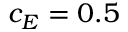Convert formula to latex. <formula><loc_0><loc_0><loc_500><loc_500>c _ { E } = 0 . 5</formula> 